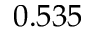<formula> <loc_0><loc_0><loc_500><loc_500>0 . 5 3 5</formula> 